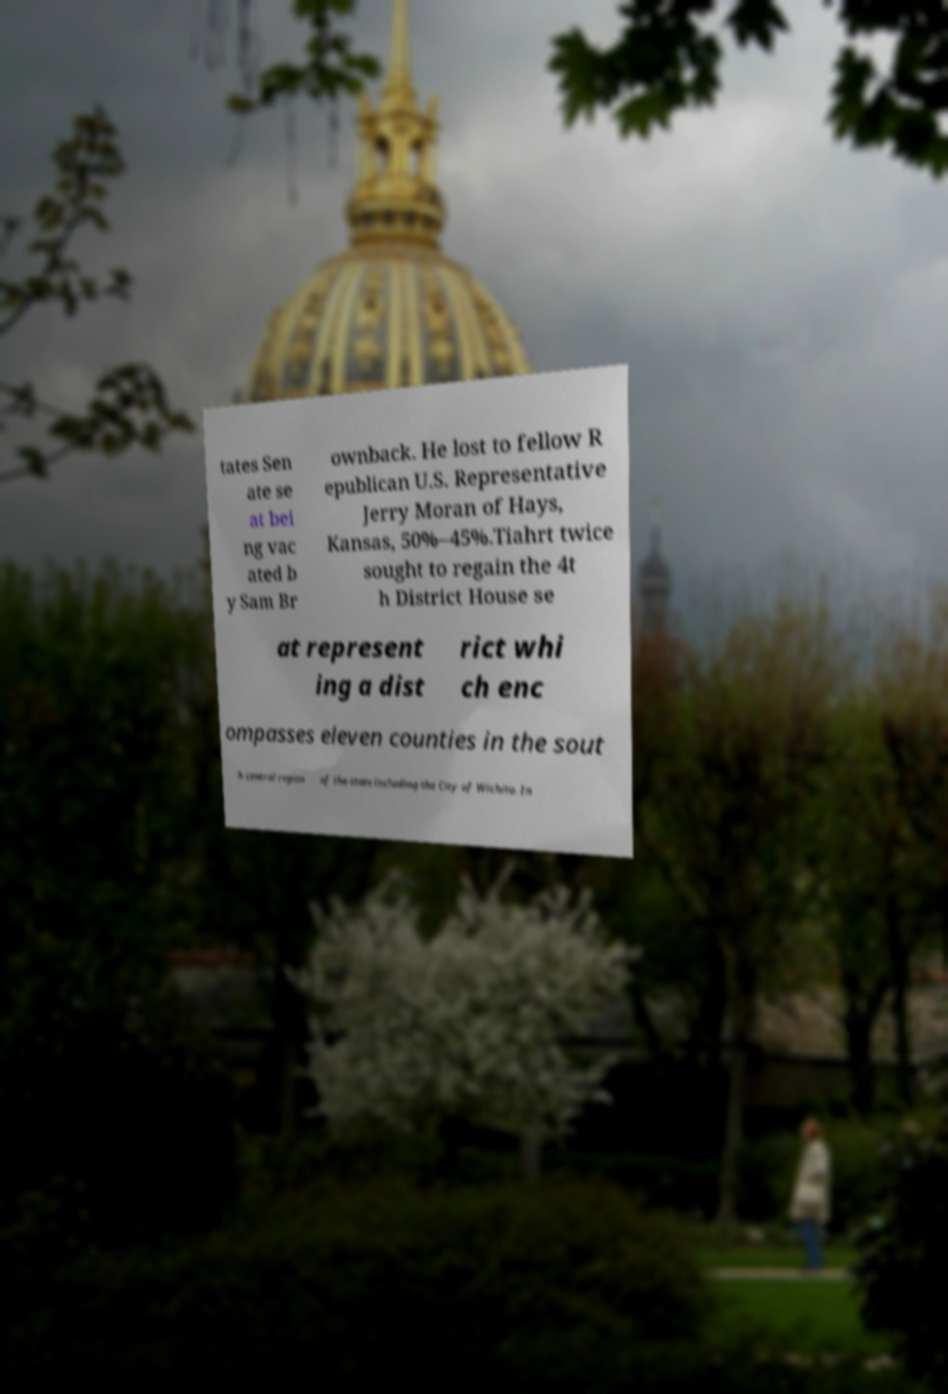I need the written content from this picture converted into text. Can you do that? tates Sen ate se at bei ng vac ated b y Sam Br ownback. He lost to fellow R epublican U.S. Representative Jerry Moran of Hays, Kansas, 50%–45%.Tiahrt twice sought to regain the 4t h District House se at represent ing a dist rict whi ch enc ompasses eleven counties in the sout h central region of the state including the City of Wichita. In 